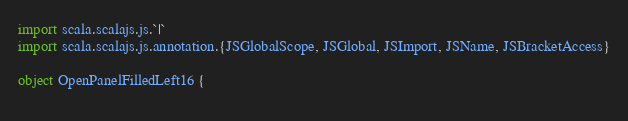<code> <loc_0><loc_0><loc_500><loc_500><_Scala_>import scala.scalajs.js.`|`
import scala.scalajs.js.annotation.{JSGlobalScope, JSGlobal, JSImport, JSName, JSBracketAccess}

object OpenPanelFilledLeft16 {
  </code> 